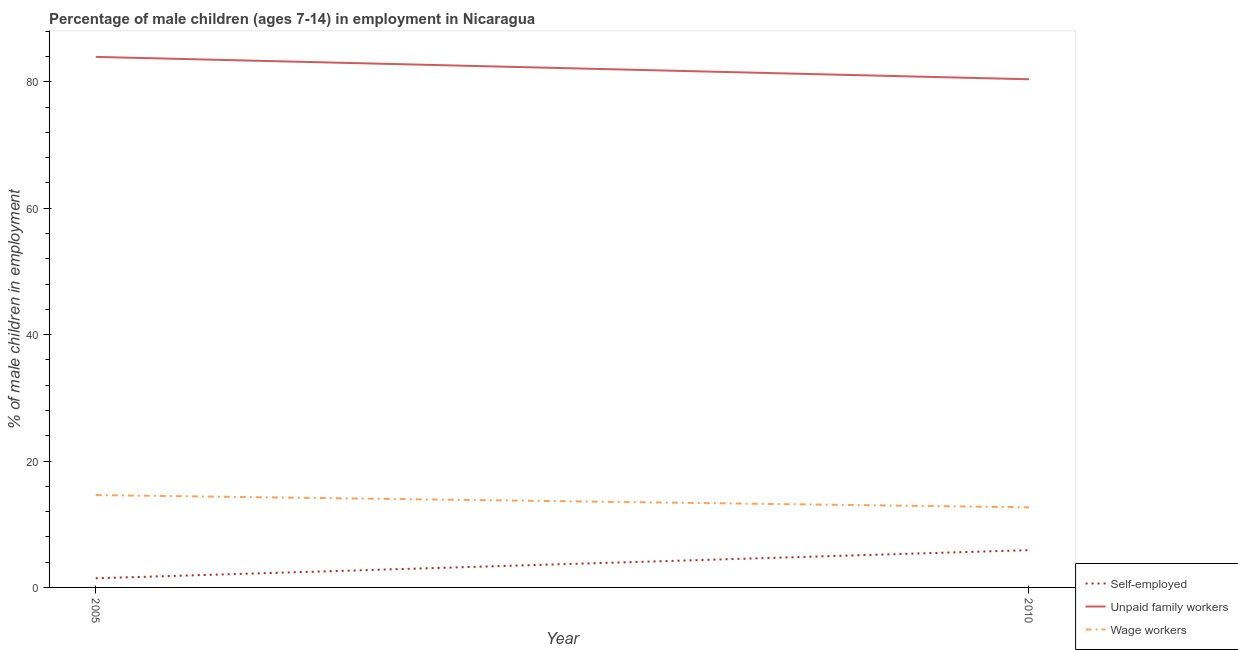How many different coloured lines are there?
Keep it short and to the point. 3. What is the percentage of children employed as wage workers in 2005?
Offer a very short reply. 14.61. Across all years, what is the maximum percentage of children employed as wage workers?
Your response must be concise. 14.61. Across all years, what is the minimum percentage of children employed as unpaid family workers?
Make the answer very short. 80.4. What is the total percentage of children employed as unpaid family workers in the graph?
Your answer should be compact. 164.34. What is the difference between the percentage of self employed children in 2005 and that in 2010?
Ensure brevity in your answer.  -4.45. What is the difference between the percentage of children employed as wage workers in 2010 and the percentage of self employed children in 2005?
Ensure brevity in your answer.  11.22. What is the average percentage of self employed children per year?
Give a very brief answer. 3.68. In the year 2010, what is the difference between the percentage of self employed children and percentage of children employed as wage workers?
Make the answer very short. -6.77. In how many years, is the percentage of children employed as wage workers greater than 12 %?
Make the answer very short. 2. What is the ratio of the percentage of self employed children in 2005 to that in 2010?
Your answer should be very brief. 0.25. Is the percentage of children employed as wage workers in 2005 less than that in 2010?
Ensure brevity in your answer.  No. Is the percentage of children employed as wage workers strictly greater than the percentage of children employed as unpaid family workers over the years?
Make the answer very short. No. Is the percentage of children employed as unpaid family workers strictly less than the percentage of self employed children over the years?
Give a very brief answer. No. How many lines are there?
Make the answer very short. 3. Does the graph contain any zero values?
Your response must be concise. No. Where does the legend appear in the graph?
Ensure brevity in your answer.  Bottom right. What is the title of the graph?
Ensure brevity in your answer.  Percentage of male children (ages 7-14) in employment in Nicaragua. Does "Ages 60+" appear as one of the legend labels in the graph?
Offer a very short reply. No. What is the label or title of the X-axis?
Provide a short and direct response. Year. What is the label or title of the Y-axis?
Give a very brief answer. % of male children in employment. What is the % of male children in employment of Self-employed in 2005?
Offer a terse response. 1.45. What is the % of male children in employment in Unpaid family workers in 2005?
Provide a short and direct response. 83.94. What is the % of male children in employment in Wage workers in 2005?
Your answer should be very brief. 14.61. What is the % of male children in employment in Self-employed in 2010?
Keep it short and to the point. 5.9. What is the % of male children in employment of Unpaid family workers in 2010?
Ensure brevity in your answer.  80.4. What is the % of male children in employment of Wage workers in 2010?
Keep it short and to the point. 12.67. Across all years, what is the maximum % of male children in employment of Unpaid family workers?
Offer a very short reply. 83.94. Across all years, what is the maximum % of male children in employment in Wage workers?
Your response must be concise. 14.61. Across all years, what is the minimum % of male children in employment of Self-employed?
Offer a very short reply. 1.45. Across all years, what is the minimum % of male children in employment in Unpaid family workers?
Provide a succinct answer. 80.4. Across all years, what is the minimum % of male children in employment of Wage workers?
Your answer should be very brief. 12.67. What is the total % of male children in employment of Self-employed in the graph?
Offer a very short reply. 7.35. What is the total % of male children in employment in Unpaid family workers in the graph?
Give a very brief answer. 164.34. What is the total % of male children in employment in Wage workers in the graph?
Offer a terse response. 27.28. What is the difference between the % of male children in employment in Self-employed in 2005 and that in 2010?
Provide a succinct answer. -4.45. What is the difference between the % of male children in employment of Unpaid family workers in 2005 and that in 2010?
Offer a very short reply. 3.54. What is the difference between the % of male children in employment of Wage workers in 2005 and that in 2010?
Make the answer very short. 1.94. What is the difference between the % of male children in employment in Self-employed in 2005 and the % of male children in employment in Unpaid family workers in 2010?
Provide a succinct answer. -78.95. What is the difference between the % of male children in employment in Self-employed in 2005 and the % of male children in employment in Wage workers in 2010?
Your answer should be very brief. -11.22. What is the difference between the % of male children in employment in Unpaid family workers in 2005 and the % of male children in employment in Wage workers in 2010?
Ensure brevity in your answer.  71.27. What is the average % of male children in employment in Self-employed per year?
Keep it short and to the point. 3.67. What is the average % of male children in employment of Unpaid family workers per year?
Your response must be concise. 82.17. What is the average % of male children in employment in Wage workers per year?
Keep it short and to the point. 13.64. In the year 2005, what is the difference between the % of male children in employment in Self-employed and % of male children in employment in Unpaid family workers?
Your answer should be compact. -82.49. In the year 2005, what is the difference between the % of male children in employment of Self-employed and % of male children in employment of Wage workers?
Your response must be concise. -13.16. In the year 2005, what is the difference between the % of male children in employment of Unpaid family workers and % of male children in employment of Wage workers?
Your answer should be very brief. 69.33. In the year 2010, what is the difference between the % of male children in employment in Self-employed and % of male children in employment in Unpaid family workers?
Give a very brief answer. -74.5. In the year 2010, what is the difference between the % of male children in employment in Self-employed and % of male children in employment in Wage workers?
Keep it short and to the point. -6.77. In the year 2010, what is the difference between the % of male children in employment in Unpaid family workers and % of male children in employment in Wage workers?
Provide a succinct answer. 67.73. What is the ratio of the % of male children in employment in Self-employed in 2005 to that in 2010?
Provide a short and direct response. 0.25. What is the ratio of the % of male children in employment in Unpaid family workers in 2005 to that in 2010?
Provide a short and direct response. 1.04. What is the ratio of the % of male children in employment of Wage workers in 2005 to that in 2010?
Keep it short and to the point. 1.15. What is the difference between the highest and the second highest % of male children in employment of Self-employed?
Your answer should be compact. 4.45. What is the difference between the highest and the second highest % of male children in employment in Unpaid family workers?
Your answer should be very brief. 3.54. What is the difference between the highest and the second highest % of male children in employment in Wage workers?
Provide a succinct answer. 1.94. What is the difference between the highest and the lowest % of male children in employment of Self-employed?
Your response must be concise. 4.45. What is the difference between the highest and the lowest % of male children in employment of Unpaid family workers?
Your answer should be compact. 3.54. What is the difference between the highest and the lowest % of male children in employment of Wage workers?
Ensure brevity in your answer.  1.94. 